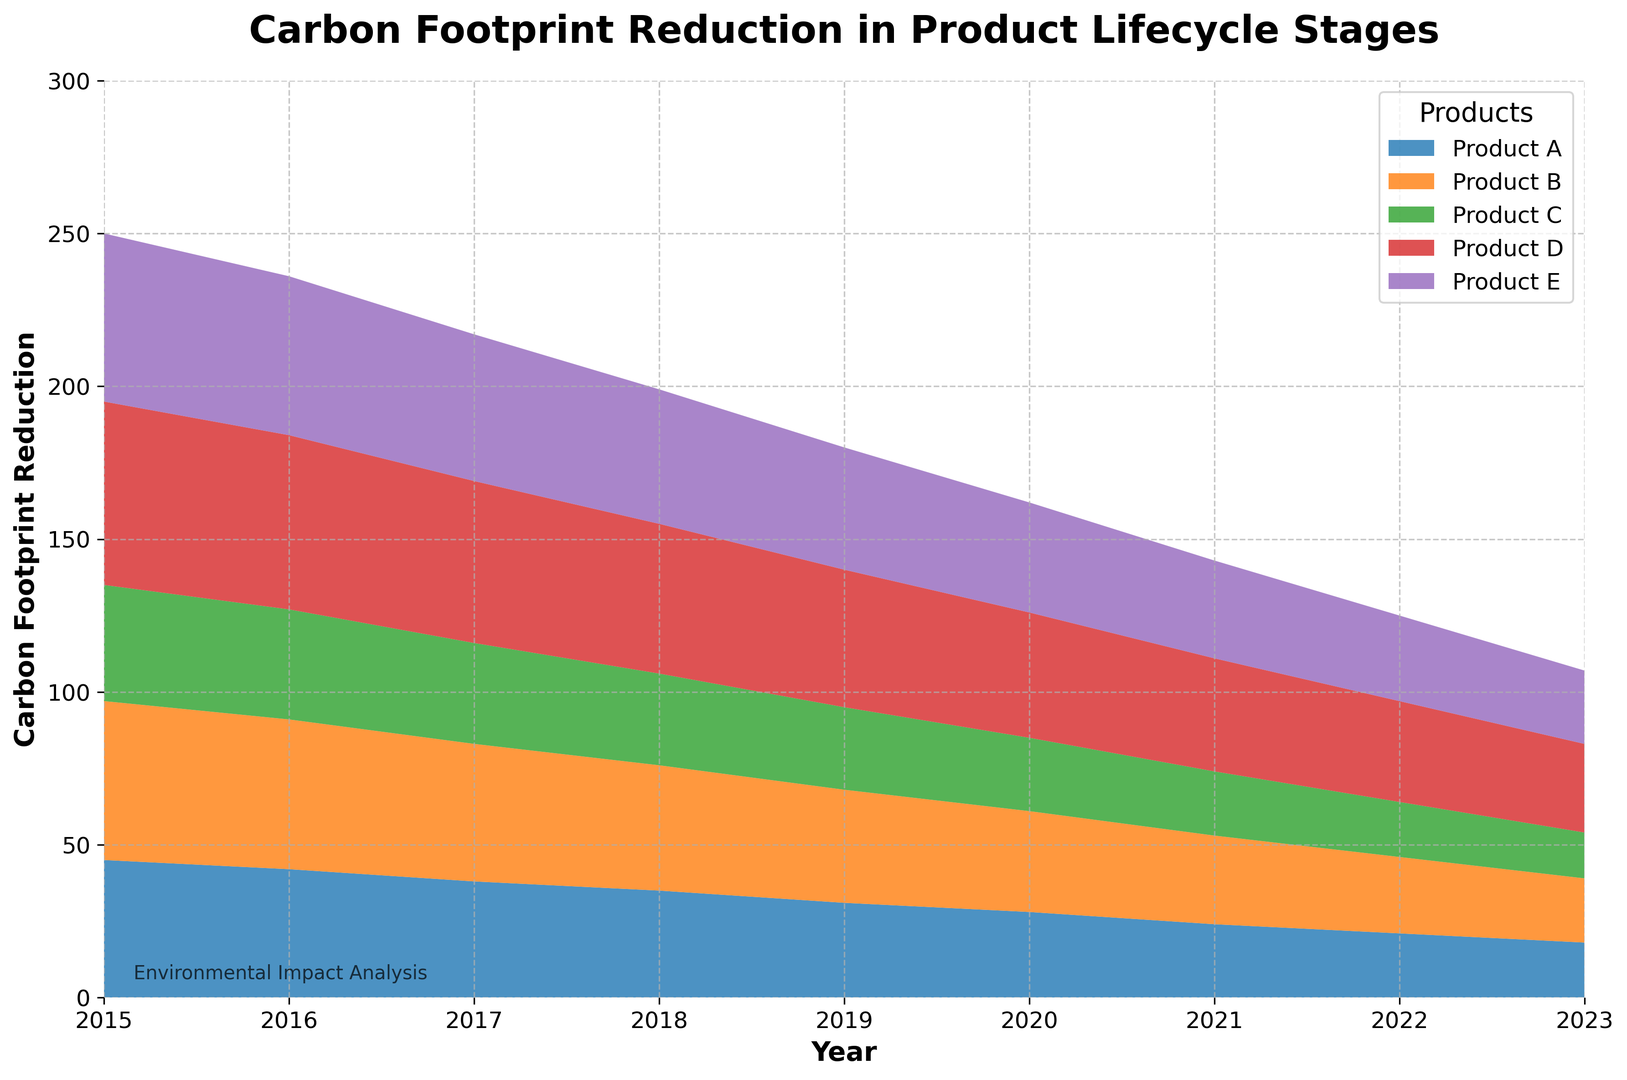What is the overall trend in the carbon footprint reduction for Product A from 2015 to 2023? Observe the area representing Product A over the years. The trend shows a consistent decline from 45 in 2015 to 18 in 2023.
Answer: consistent decline Which product had the highest carbon footprint reduction in 2015? Look at the heights of the areas for each product in 2015. Product D has the highest value at 60.
Answer: Product D By how much did the carbon footprint reduction for Product E decrease from 2015 to 2023? Subtract the carbon footprint reduction value of Product E in 2023 (24) from its value in 2015 (55). So, 55 - 24 = 31.
Answer: 31 Which year shows the largest difference in carbon footprint reduction between Product B and Product C? Calculate the differences between Product B and Product C for each year and find the maximum: 2015 (52-38=14), 2016 (49-36=13), 2017 (45-33=12), 2018 (41-30=11), 2019 (37-27=10), 2020 (33-24=9), 2021 (29-21=8), 2022 (25-18=7), 2023 (21-15=6). The largest difference is 14 in 2015.
Answer: 2015 Which product shows the most consistent reduction in carbon footprint over the years? Observe the smoothness and uniformity of the decline for each product. Product A exhibits a steady and consistent reduction.
Answer: Product A Is the reduction in carbon footprint for Product D in 2023 less than that for Product C in 2018? Compare the values: Product D in 2023 is 29 and Product C in 2018 is 30. 29 < 30.
Answer: Yes How many products had a carbon footprint reduction value below 30 in 2021? Identify products with values below 30 in 2021: Product A (24), Product C (21), Product E (32), Product D (37), and Product B (29). Only Product A, Product B, and Product C fall below 30.
Answer: 3 What is the average carbon footprint reduction for Product B from 2015 to 2023? Sum the values for Product B from 2015 to 2023 and divide by the number of years: (52+49+45+41+37+33+29+25+21) / 9 = 37.
Answer: 37 In which year did Product E achieve its largest year-on-year reduction in carbon footprint? Calculate year-on-year reductions for Product E: 2016 (55-52=3), 2017 (52-48=4), 2018 (48-44=4), 2019 (44-40=4), 2020 (40-36=4), 2021 (36-32=4), 2022 (32-28=4), 2023 (28-24=4). The largest reduction (4) occurs in multiple years.
Answer: 2017 For which product is the reduction area the smallest in 2023? Compare the areas representing each product in 2023. Product C, with the value of 15, has the smallest area.
Answer: Product C 